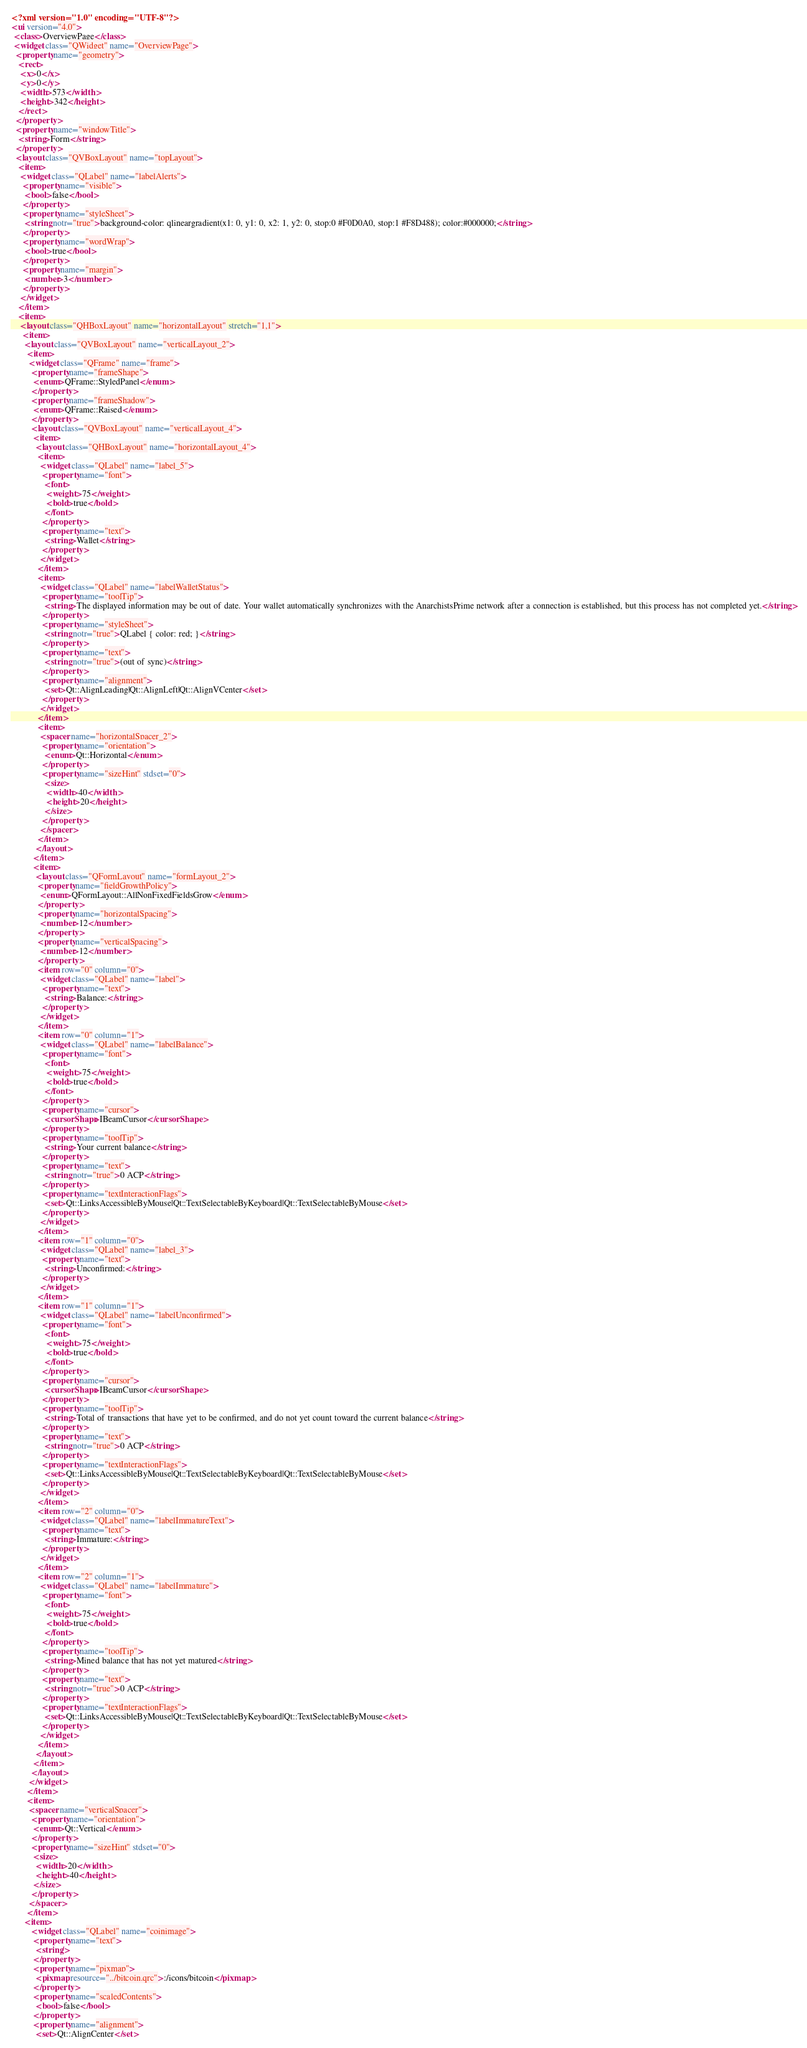<code> <loc_0><loc_0><loc_500><loc_500><_XML_><?xml version="1.0" encoding="UTF-8"?>
<ui version="4.0">
 <class>OverviewPage</class>
 <widget class="QWidget" name="OverviewPage">
  <property name="geometry">
   <rect>
    <x>0</x>
    <y>0</y>
    <width>573</width>
    <height>342</height>
   </rect>
  </property>
  <property name="windowTitle">
   <string>Form</string>
  </property>
  <layout class="QVBoxLayout" name="topLayout">
   <item>
    <widget class="QLabel" name="labelAlerts">
     <property name="visible">
      <bool>false</bool>
     </property>
     <property name="styleSheet">
      <string notr="true">background-color: qlineargradient(x1: 0, y1: 0, x2: 1, y2: 0, stop:0 #F0D0A0, stop:1 #F8D488); color:#000000;</string>
     </property>
     <property name="wordWrap">
      <bool>true</bool>
     </property>
     <property name="margin">
      <number>3</number>
     </property>
    </widget>
   </item>
   <item>
    <layout class="QHBoxLayout" name="horizontalLayout" stretch="1,1">
     <item>
      <layout class="QVBoxLayout" name="verticalLayout_2">
       <item>
        <widget class="QFrame" name="frame">
         <property name="frameShape">
          <enum>QFrame::StyledPanel</enum>
         </property>
         <property name="frameShadow">
          <enum>QFrame::Raised</enum>
         </property>
         <layout class="QVBoxLayout" name="verticalLayout_4">
          <item>
           <layout class="QHBoxLayout" name="horizontalLayout_4">
            <item>
             <widget class="QLabel" name="label_5">
              <property name="font">
               <font>
                <weight>75</weight>
                <bold>true</bold>
               </font>
              </property>
              <property name="text">
               <string>Wallet</string>
              </property>
             </widget>
            </item>
            <item>
             <widget class="QLabel" name="labelWalletStatus">
              <property name="toolTip">
               <string>The displayed information may be out of date. Your wallet automatically synchronizes with the AnarchistsPrime network after a connection is established, but this process has not completed yet.</string>
              </property>
              <property name="styleSheet">
               <string notr="true">QLabel { color: red; }</string>
              </property>
              <property name="text">
               <string notr="true">(out of sync)</string>
              </property>
              <property name="alignment">
               <set>Qt::AlignLeading|Qt::AlignLeft|Qt::AlignVCenter</set>
              </property>
             </widget>
            </item>
            <item>
             <spacer name="horizontalSpacer_2">
              <property name="orientation">
               <enum>Qt::Horizontal</enum>
              </property>
              <property name="sizeHint" stdset="0">
               <size>
                <width>40</width>
                <height>20</height>
               </size>
              </property>
             </spacer>
            </item>
           </layout>
          </item>
          <item>
           <layout class="QFormLayout" name="formLayout_2">
            <property name="fieldGrowthPolicy">
             <enum>QFormLayout::AllNonFixedFieldsGrow</enum>
            </property>
            <property name="horizontalSpacing">
             <number>12</number>
            </property>
            <property name="verticalSpacing">
             <number>12</number>
            </property>
            <item row="0" column="0">
             <widget class="QLabel" name="label">
              <property name="text">
               <string>Balance:</string>
              </property>
             </widget>
            </item>
            <item row="0" column="1">
             <widget class="QLabel" name="labelBalance">
              <property name="font">
               <font>
                <weight>75</weight>
                <bold>true</bold>
               </font>
              </property>
              <property name="cursor">
               <cursorShape>IBeamCursor</cursorShape>
              </property>
              <property name="toolTip">
               <string>Your current balance</string>
              </property>
              <property name="text">
               <string notr="true">0 ACP</string>
              </property>
              <property name="textInteractionFlags">
               <set>Qt::LinksAccessibleByMouse|Qt::TextSelectableByKeyboard|Qt::TextSelectableByMouse</set>
              </property>
             </widget>
            </item>
            <item row="1" column="0">
             <widget class="QLabel" name="label_3">
              <property name="text">
               <string>Unconfirmed:</string>
              </property>
             </widget>
            </item>
            <item row="1" column="1">
             <widget class="QLabel" name="labelUnconfirmed">
              <property name="font">
               <font>
                <weight>75</weight>
                <bold>true</bold>
               </font>
              </property>
              <property name="cursor">
               <cursorShape>IBeamCursor</cursorShape>
              </property>
              <property name="toolTip">
               <string>Total of transactions that have yet to be confirmed, and do not yet count toward the current balance</string>
              </property>
              <property name="text">
               <string notr="true">0 ACP</string>
              </property>
              <property name="textInteractionFlags">
               <set>Qt::LinksAccessibleByMouse|Qt::TextSelectableByKeyboard|Qt::TextSelectableByMouse</set>
              </property>
             </widget>
            </item>
            <item row="2" column="0">
             <widget class="QLabel" name="labelImmatureText">
              <property name="text">
               <string>Immature:</string>
              </property>
             </widget>
            </item>
            <item row="2" column="1">
             <widget class="QLabel" name="labelImmature">
              <property name="font">
               <font>
                <weight>75</weight>
                <bold>true</bold>
               </font>
              </property>
              <property name="toolTip">
               <string>Mined balance that has not yet matured</string>
              </property>
              <property name="text">
               <string notr="true">0 ACP</string>
              </property>
              <property name="textInteractionFlags">
               <set>Qt::LinksAccessibleByMouse|Qt::TextSelectableByKeyboard|Qt::TextSelectableByMouse</set>
              </property>
             </widget>
            </item>
           </layout>
          </item>
         </layout>
        </widget>
       </item>
       <item>
        <spacer name="verticalSpacer">
         <property name="orientation">
          <enum>Qt::Vertical</enum>
         </property>
         <property name="sizeHint" stdset="0">
          <size>
           <width>20</width>
           <height>40</height>
          </size>
         </property>
        </spacer>
       </item>
      <item>
         <widget class="QLabel" name="coinimage">
          <property name="text">
           <string/>
          </property>
          <property name="pixmap">
           <pixmap resource="../bitcoin.qrc">:/icons/bitcoin</pixmap>
          </property>
          <property name="scaledContents">
           <bool>false</bool>
          </property>
          <property name="alignment">
           <set>Qt::AlignCenter</set></code> 